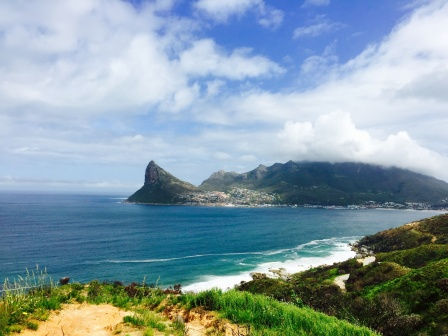What might be the sounds and smells in the setting of this image? In this coastal setting, you would likely be greeted by a symphony of soothing sounds and refreshing scents. The gentle yet constant roar of the ocean waves crashing against the shore would serve as a calming backdrop. The calls of seagulls and other coastal birds would add a lively chorus, occasionally punctuated by the distant bark of a sea lion or the splash of a dolphin breaking the surface.

The air would be infused with the salty tang of the sea, mixed with the fresh, earthy aroma of the green hills and vegetation. Depending on the time of day, you might also catch the faint scent of blooming coastal flowers or the subtle smokiness from a distant bonfire in the small town. This blend of sounds and smells would create an invigorating and immersive sensory experience, embodying the essence of the coastal landscape. 